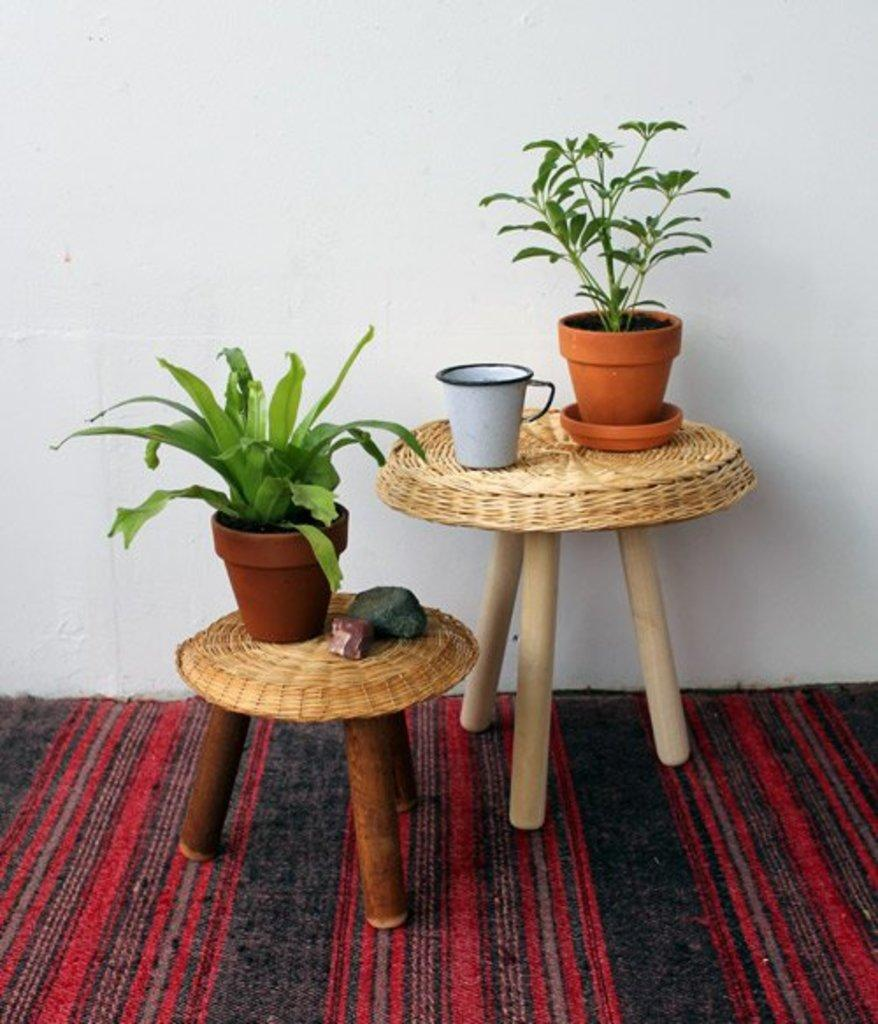What type of objects are on the tables in the image? There are plants on tables in the image. Can you describe any other objects in the image? Yes, there is a cup in the image. What type of frame is surrounding the plants on the tables in the image? There is no frame surrounding the plants on the tables in the image. Can you see any wool in the image? There is no wool present in the image. 